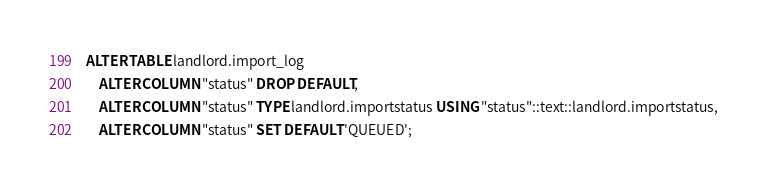<code> <loc_0><loc_0><loc_500><loc_500><_SQL_>
ALTER TABLE landlord.import_log
    ALTER COLUMN "status" DROP DEFAULT,
    ALTER COLUMN "status" TYPE landlord.importstatus USING "status"::text::landlord.importstatus,
    ALTER COLUMN "status" SET DEFAULT 'QUEUED';</code> 